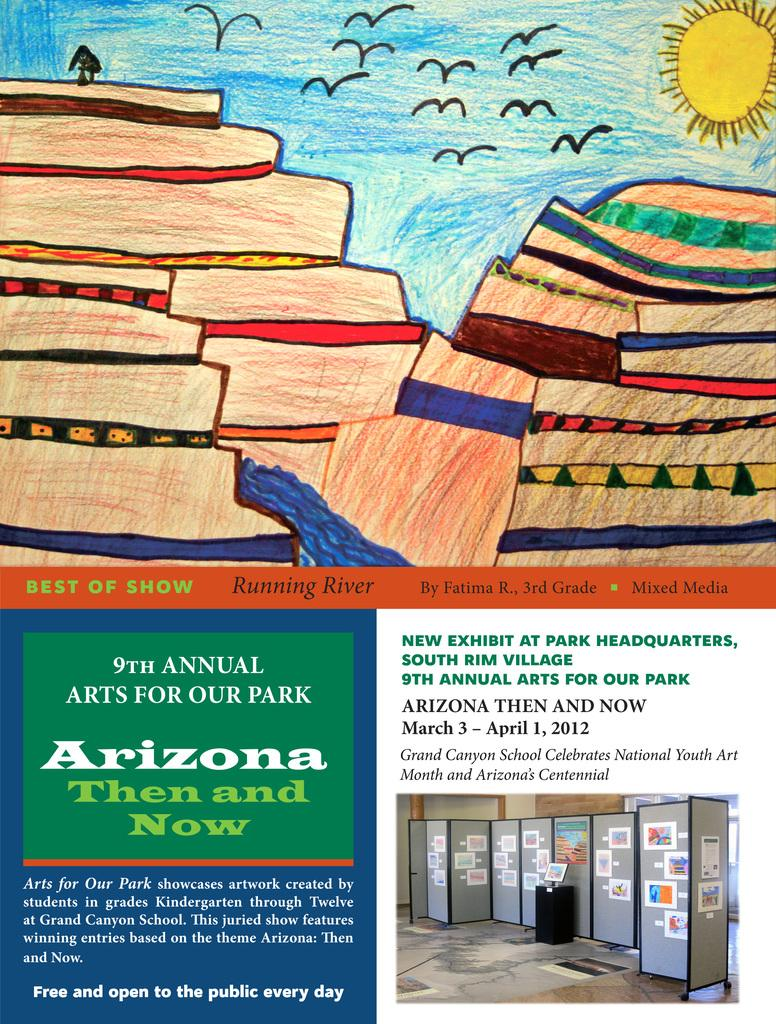<image>
Share a concise interpretation of the image provided. A crayon drawing of a valley and river displayed at teh 9th Annual Arts For Our Park exhibition. 